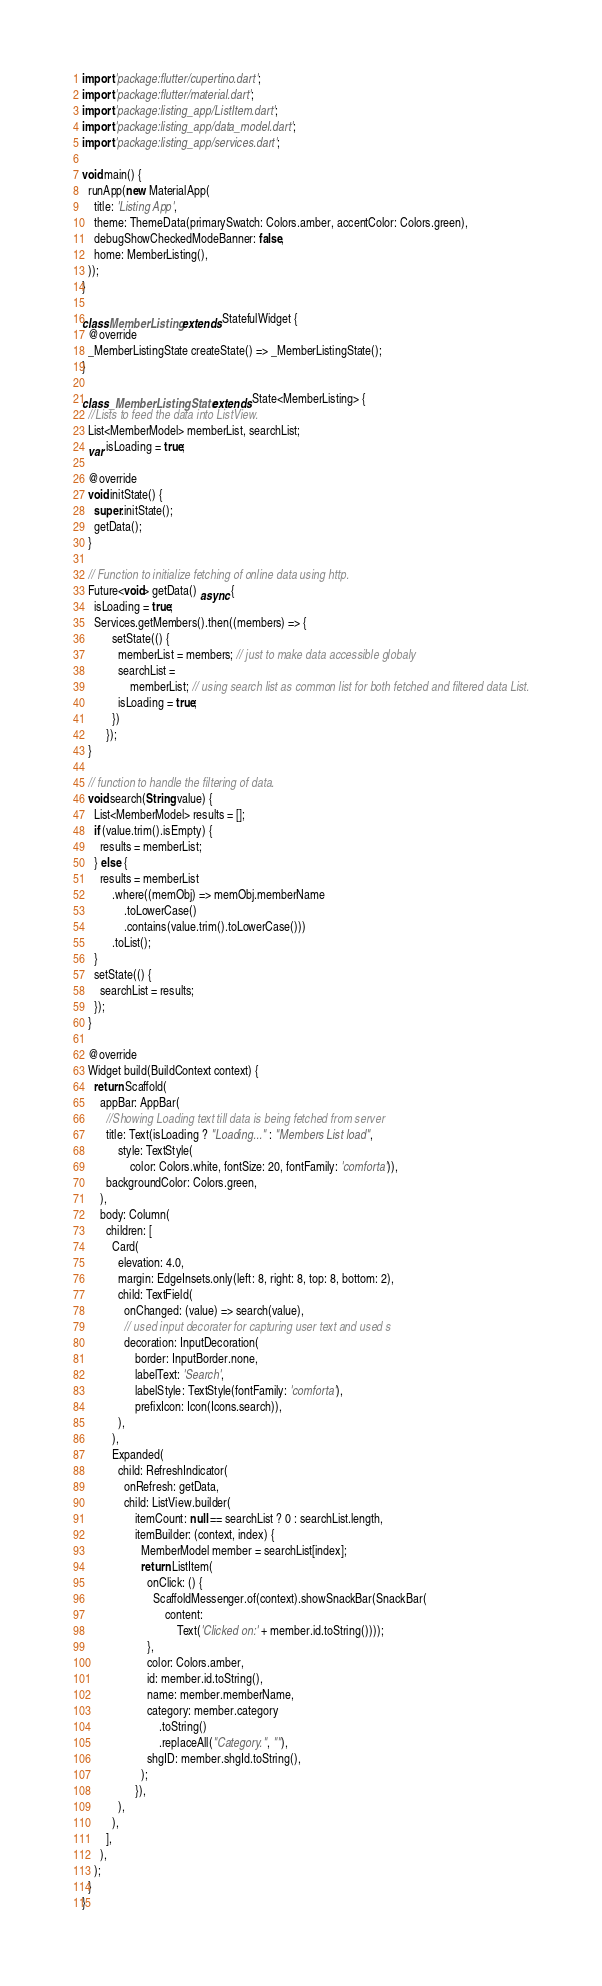Convert code to text. <code><loc_0><loc_0><loc_500><loc_500><_Dart_>import 'package:flutter/cupertino.dart';
import 'package:flutter/material.dart';
import 'package:listing_app/ListItem.dart';
import 'package:listing_app/data_model.dart';
import 'package:listing_app/services.dart';

void main() {
  runApp(new MaterialApp(
    title: 'Listing App',
    theme: ThemeData(primarySwatch: Colors.amber, accentColor: Colors.green),
    debugShowCheckedModeBanner: false,
    home: MemberListing(),
  ));
}

class MemberListing extends StatefulWidget {
  @override
  _MemberListingState createState() => _MemberListingState();
}

class _MemberListingState extends State<MemberListing> {
  //Lists to feed the data into ListView.
  List<MemberModel> memberList, searchList;
  var isLoading = true;

  @override
  void initState() {
    super.initState();
    getData();
  }

  // Function to initialize fetching of online data using http.
  Future<void> getData() async {
    isLoading = true;
    Services.getMembers().then((members) => {
          setState(() {
            memberList = members; // just to make data accessible globaly
            searchList =
                memberList; // using search list as common list for both fetched and filtered data List.
            isLoading = true;
          })
        });
  }

  // function to handle the filtering of data.
  void search(String value) {
    List<MemberModel> results = [];
    if (value.trim().isEmpty) {
      results = memberList;
    } else {
      results = memberList
          .where((memObj) => memObj.memberName
              .toLowerCase()
              .contains(value.trim().toLowerCase()))
          .toList();
    }
    setState(() {
      searchList = results;
    });
  }

  @override
  Widget build(BuildContext context) {
    return Scaffold(
      appBar: AppBar(
        //Showing Loading text till data is being fetched from server
        title: Text(isLoading ? "Loading..." : "Members List load",
            style: TextStyle(
                color: Colors.white, fontSize: 20, fontFamily: 'comforta')),
        backgroundColor: Colors.green,
      ),
      body: Column(
        children: [
          Card(
            elevation: 4.0,
            margin: EdgeInsets.only(left: 8, right: 8, top: 8, bottom: 2),
            child: TextField(
              onChanged: (value) => search(value),
              // used input decorater for capturing user text and used s
              decoration: InputDecoration(
                  border: InputBorder.none,
                  labelText: 'Search',
                  labelStyle: TextStyle(fontFamily: 'comforta'),
                  prefixIcon: Icon(Icons.search)),
            ),
          ),
          Expanded(
            child: RefreshIndicator(
              onRefresh: getData,
              child: ListView.builder(
                  itemCount: null == searchList ? 0 : searchList.length,
                  itemBuilder: (context, index) {
                    MemberModel member = searchList[index];
                    return ListItem(
                      onClick: () {
                        ScaffoldMessenger.of(context).showSnackBar(SnackBar(
                            content:
                                Text('Clicked on:' + member.id.toString())));
                      },
                      color: Colors.amber,
                      id: member.id.toString(),
                      name: member.memberName,
                      category: member.category
                          .toString()
                          .replaceAll("Category.", ""),
                      shgID: member.shgId.toString(),
                    );
                  }),
            ),
          ),
        ],
      ),
    );
  }
}
</code> 